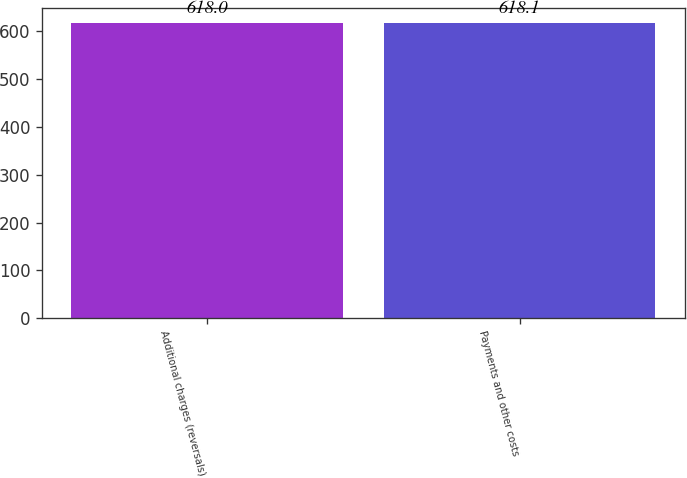Convert chart. <chart><loc_0><loc_0><loc_500><loc_500><bar_chart><fcel>Additional charges (reversals)<fcel>Payments and other costs<nl><fcel>618<fcel>618.1<nl></chart> 